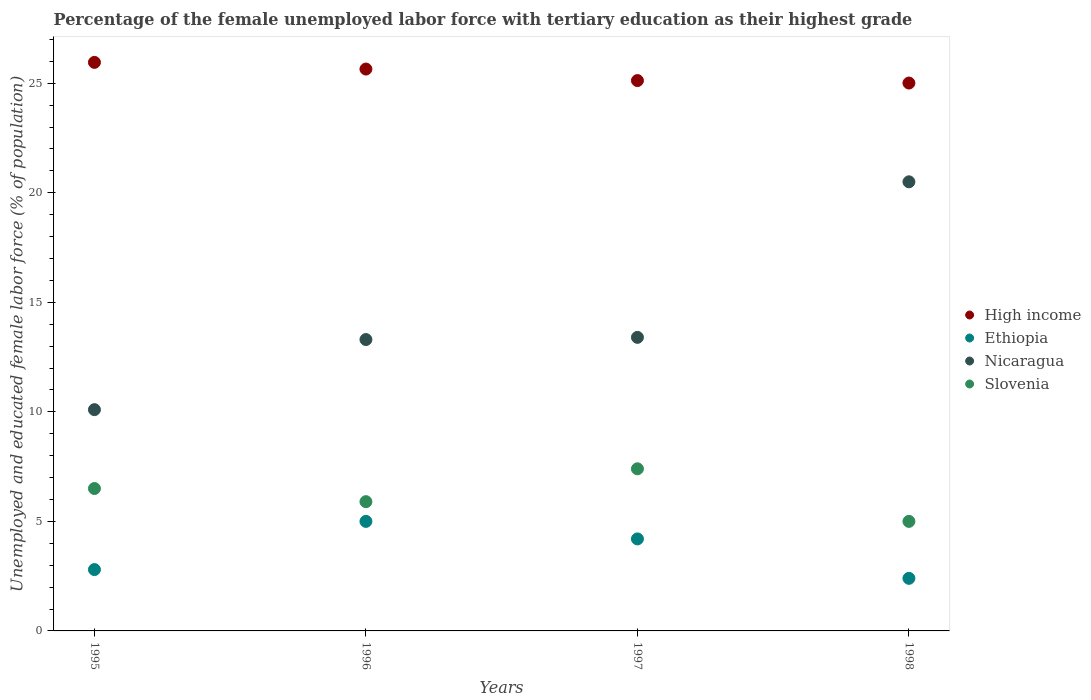Is the number of dotlines equal to the number of legend labels?
Make the answer very short. Yes. What is the percentage of the unemployed female labor force with tertiary education in Ethiopia in 1995?
Offer a very short reply. 2.8. Across all years, what is the minimum percentage of the unemployed female labor force with tertiary education in Nicaragua?
Provide a succinct answer. 10.1. What is the total percentage of the unemployed female labor force with tertiary education in Ethiopia in the graph?
Give a very brief answer. 14.4. What is the difference between the percentage of the unemployed female labor force with tertiary education in Nicaragua in 1995 and that in 1998?
Offer a terse response. -10.4. What is the difference between the percentage of the unemployed female labor force with tertiary education in Nicaragua in 1995 and the percentage of the unemployed female labor force with tertiary education in Ethiopia in 1996?
Provide a short and direct response. 5.1. What is the average percentage of the unemployed female labor force with tertiary education in Slovenia per year?
Your answer should be compact. 6.2. In the year 1998, what is the difference between the percentage of the unemployed female labor force with tertiary education in Slovenia and percentage of the unemployed female labor force with tertiary education in Ethiopia?
Make the answer very short. 2.6. In how many years, is the percentage of the unemployed female labor force with tertiary education in Slovenia greater than 19 %?
Make the answer very short. 0. What is the ratio of the percentage of the unemployed female labor force with tertiary education in Nicaragua in 1995 to that in 1997?
Ensure brevity in your answer.  0.75. Is the percentage of the unemployed female labor force with tertiary education in Ethiopia in 1995 less than that in 1996?
Make the answer very short. Yes. What is the difference between the highest and the second highest percentage of the unemployed female labor force with tertiary education in Ethiopia?
Your answer should be very brief. 0.8. What is the difference between the highest and the lowest percentage of the unemployed female labor force with tertiary education in High income?
Your answer should be very brief. 0.94. In how many years, is the percentage of the unemployed female labor force with tertiary education in High income greater than the average percentage of the unemployed female labor force with tertiary education in High income taken over all years?
Keep it short and to the point. 2. Is the sum of the percentage of the unemployed female labor force with tertiary education in Ethiopia in 1995 and 1998 greater than the maximum percentage of the unemployed female labor force with tertiary education in Nicaragua across all years?
Provide a short and direct response. No. Is it the case that in every year, the sum of the percentage of the unemployed female labor force with tertiary education in Slovenia and percentage of the unemployed female labor force with tertiary education in Nicaragua  is greater than the sum of percentage of the unemployed female labor force with tertiary education in High income and percentage of the unemployed female labor force with tertiary education in Ethiopia?
Provide a short and direct response. Yes. Is it the case that in every year, the sum of the percentage of the unemployed female labor force with tertiary education in Nicaragua and percentage of the unemployed female labor force with tertiary education in High income  is greater than the percentage of the unemployed female labor force with tertiary education in Ethiopia?
Your response must be concise. Yes. Does the percentage of the unemployed female labor force with tertiary education in Slovenia monotonically increase over the years?
Your response must be concise. No. Does the graph contain any zero values?
Make the answer very short. No. Does the graph contain grids?
Your answer should be compact. No. What is the title of the graph?
Give a very brief answer. Percentage of the female unemployed labor force with tertiary education as their highest grade. What is the label or title of the X-axis?
Ensure brevity in your answer.  Years. What is the label or title of the Y-axis?
Keep it short and to the point. Unemployed and educated female labor force (% of population). What is the Unemployed and educated female labor force (% of population) in High income in 1995?
Your response must be concise. 25.95. What is the Unemployed and educated female labor force (% of population) in Ethiopia in 1995?
Offer a terse response. 2.8. What is the Unemployed and educated female labor force (% of population) of Nicaragua in 1995?
Your response must be concise. 10.1. What is the Unemployed and educated female labor force (% of population) in High income in 1996?
Make the answer very short. 25.65. What is the Unemployed and educated female labor force (% of population) in Ethiopia in 1996?
Keep it short and to the point. 5. What is the Unemployed and educated female labor force (% of population) in Nicaragua in 1996?
Your answer should be very brief. 13.3. What is the Unemployed and educated female labor force (% of population) of Slovenia in 1996?
Your answer should be very brief. 5.9. What is the Unemployed and educated female labor force (% of population) of High income in 1997?
Your answer should be compact. 25.12. What is the Unemployed and educated female labor force (% of population) in Ethiopia in 1997?
Offer a terse response. 4.2. What is the Unemployed and educated female labor force (% of population) in Nicaragua in 1997?
Offer a very short reply. 13.4. What is the Unemployed and educated female labor force (% of population) of Slovenia in 1997?
Offer a very short reply. 7.4. What is the Unemployed and educated female labor force (% of population) of High income in 1998?
Your response must be concise. 25.01. What is the Unemployed and educated female labor force (% of population) in Ethiopia in 1998?
Ensure brevity in your answer.  2.4. What is the Unemployed and educated female labor force (% of population) in Slovenia in 1998?
Provide a short and direct response. 5. Across all years, what is the maximum Unemployed and educated female labor force (% of population) of High income?
Your answer should be very brief. 25.95. Across all years, what is the maximum Unemployed and educated female labor force (% of population) of Nicaragua?
Provide a short and direct response. 20.5. Across all years, what is the maximum Unemployed and educated female labor force (% of population) in Slovenia?
Give a very brief answer. 7.4. Across all years, what is the minimum Unemployed and educated female labor force (% of population) of High income?
Offer a terse response. 25.01. Across all years, what is the minimum Unemployed and educated female labor force (% of population) of Ethiopia?
Your answer should be very brief. 2.4. Across all years, what is the minimum Unemployed and educated female labor force (% of population) of Nicaragua?
Ensure brevity in your answer.  10.1. What is the total Unemployed and educated female labor force (% of population) in High income in the graph?
Ensure brevity in your answer.  101.73. What is the total Unemployed and educated female labor force (% of population) of Nicaragua in the graph?
Your response must be concise. 57.3. What is the total Unemployed and educated female labor force (% of population) of Slovenia in the graph?
Ensure brevity in your answer.  24.8. What is the difference between the Unemployed and educated female labor force (% of population) in High income in 1995 and that in 1996?
Give a very brief answer. 0.3. What is the difference between the Unemployed and educated female labor force (% of population) in Ethiopia in 1995 and that in 1996?
Make the answer very short. -2.2. What is the difference between the Unemployed and educated female labor force (% of population) of High income in 1995 and that in 1997?
Provide a succinct answer. 0.83. What is the difference between the Unemployed and educated female labor force (% of population) of Ethiopia in 1995 and that in 1997?
Your answer should be very brief. -1.4. What is the difference between the Unemployed and educated female labor force (% of population) in Nicaragua in 1995 and that in 1997?
Your response must be concise. -3.3. What is the difference between the Unemployed and educated female labor force (% of population) in Slovenia in 1995 and that in 1997?
Your answer should be compact. -0.9. What is the difference between the Unemployed and educated female labor force (% of population) of High income in 1995 and that in 1998?
Your answer should be compact. 0.94. What is the difference between the Unemployed and educated female labor force (% of population) in High income in 1996 and that in 1997?
Your answer should be very brief. 0.53. What is the difference between the Unemployed and educated female labor force (% of population) of Slovenia in 1996 and that in 1997?
Your response must be concise. -1.5. What is the difference between the Unemployed and educated female labor force (% of population) of High income in 1996 and that in 1998?
Keep it short and to the point. 0.64. What is the difference between the Unemployed and educated female labor force (% of population) in High income in 1997 and that in 1998?
Provide a succinct answer. 0.11. What is the difference between the Unemployed and educated female labor force (% of population) in Ethiopia in 1997 and that in 1998?
Give a very brief answer. 1.8. What is the difference between the Unemployed and educated female labor force (% of population) in Nicaragua in 1997 and that in 1998?
Provide a succinct answer. -7.1. What is the difference between the Unemployed and educated female labor force (% of population) in Slovenia in 1997 and that in 1998?
Your answer should be compact. 2.4. What is the difference between the Unemployed and educated female labor force (% of population) of High income in 1995 and the Unemployed and educated female labor force (% of population) of Ethiopia in 1996?
Give a very brief answer. 20.95. What is the difference between the Unemployed and educated female labor force (% of population) in High income in 1995 and the Unemployed and educated female labor force (% of population) in Nicaragua in 1996?
Your answer should be compact. 12.65. What is the difference between the Unemployed and educated female labor force (% of population) in High income in 1995 and the Unemployed and educated female labor force (% of population) in Slovenia in 1996?
Make the answer very short. 20.05. What is the difference between the Unemployed and educated female labor force (% of population) of Ethiopia in 1995 and the Unemployed and educated female labor force (% of population) of Nicaragua in 1996?
Keep it short and to the point. -10.5. What is the difference between the Unemployed and educated female labor force (% of population) in Ethiopia in 1995 and the Unemployed and educated female labor force (% of population) in Slovenia in 1996?
Ensure brevity in your answer.  -3.1. What is the difference between the Unemployed and educated female labor force (% of population) of High income in 1995 and the Unemployed and educated female labor force (% of population) of Ethiopia in 1997?
Make the answer very short. 21.75. What is the difference between the Unemployed and educated female labor force (% of population) in High income in 1995 and the Unemployed and educated female labor force (% of population) in Nicaragua in 1997?
Your response must be concise. 12.55. What is the difference between the Unemployed and educated female labor force (% of population) in High income in 1995 and the Unemployed and educated female labor force (% of population) in Slovenia in 1997?
Your answer should be very brief. 18.55. What is the difference between the Unemployed and educated female labor force (% of population) of Ethiopia in 1995 and the Unemployed and educated female labor force (% of population) of Slovenia in 1997?
Offer a very short reply. -4.6. What is the difference between the Unemployed and educated female labor force (% of population) in High income in 1995 and the Unemployed and educated female labor force (% of population) in Ethiopia in 1998?
Ensure brevity in your answer.  23.55. What is the difference between the Unemployed and educated female labor force (% of population) of High income in 1995 and the Unemployed and educated female labor force (% of population) of Nicaragua in 1998?
Your answer should be compact. 5.45. What is the difference between the Unemployed and educated female labor force (% of population) in High income in 1995 and the Unemployed and educated female labor force (% of population) in Slovenia in 1998?
Make the answer very short. 20.95. What is the difference between the Unemployed and educated female labor force (% of population) of Ethiopia in 1995 and the Unemployed and educated female labor force (% of population) of Nicaragua in 1998?
Your response must be concise. -17.7. What is the difference between the Unemployed and educated female labor force (% of population) in High income in 1996 and the Unemployed and educated female labor force (% of population) in Ethiopia in 1997?
Your answer should be compact. 21.45. What is the difference between the Unemployed and educated female labor force (% of population) in High income in 1996 and the Unemployed and educated female labor force (% of population) in Nicaragua in 1997?
Your answer should be compact. 12.25. What is the difference between the Unemployed and educated female labor force (% of population) of High income in 1996 and the Unemployed and educated female labor force (% of population) of Slovenia in 1997?
Your answer should be very brief. 18.25. What is the difference between the Unemployed and educated female labor force (% of population) in High income in 1996 and the Unemployed and educated female labor force (% of population) in Ethiopia in 1998?
Offer a very short reply. 23.25. What is the difference between the Unemployed and educated female labor force (% of population) in High income in 1996 and the Unemployed and educated female labor force (% of population) in Nicaragua in 1998?
Make the answer very short. 5.15. What is the difference between the Unemployed and educated female labor force (% of population) of High income in 1996 and the Unemployed and educated female labor force (% of population) of Slovenia in 1998?
Make the answer very short. 20.65. What is the difference between the Unemployed and educated female labor force (% of population) of Ethiopia in 1996 and the Unemployed and educated female labor force (% of population) of Nicaragua in 1998?
Provide a short and direct response. -15.5. What is the difference between the Unemployed and educated female labor force (% of population) of Nicaragua in 1996 and the Unemployed and educated female labor force (% of population) of Slovenia in 1998?
Give a very brief answer. 8.3. What is the difference between the Unemployed and educated female labor force (% of population) of High income in 1997 and the Unemployed and educated female labor force (% of population) of Ethiopia in 1998?
Provide a short and direct response. 22.72. What is the difference between the Unemployed and educated female labor force (% of population) in High income in 1997 and the Unemployed and educated female labor force (% of population) in Nicaragua in 1998?
Your answer should be very brief. 4.62. What is the difference between the Unemployed and educated female labor force (% of population) of High income in 1997 and the Unemployed and educated female labor force (% of population) of Slovenia in 1998?
Ensure brevity in your answer.  20.12. What is the difference between the Unemployed and educated female labor force (% of population) of Ethiopia in 1997 and the Unemployed and educated female labor force (% of population) of Nicaragua in 1998?
Ensure brevity in your answer.  -16.3. What is the average Unemployed and educated female labor force (% of population) in High income per year?
Offer a very short reply. 25.43. What is the average Unemployed and educated female labor force (% of population) of Nicaragua per year?
Your answer should be very brief. 14.32. What is the average Unemployed and educated female labor force (% of population) of Slovenia per year?
Provide a succinct answer. 6.2. In the year 1995, what is the difference between the Unemployed and educated female labor force (% of population) of High income and Unemployed and educated female labor force (% of population) of Ethiopia?
Make the answer very short. 23.15. In the year 1995, what is the difference between the Unemployed and educated female labor force (% of population) of High income and Unemployed and educated female labor force (% of population) of Nicaragua?
Ensure brevity in your answer.  15.85. In the year 1995, what is the difference between the Unemployed and educated female labor force (% of population) in High income and Unemployed and educated female labor force (% of population) in Slovenia?
Your answer should be very brief. 19.45. In the year 1995, what is the difference between the Unemployed and educated female labor force (% of population) of Ethiopia and Unemployed and educated female labor force (% of population) of Nicaragua?
Your response must be concise. -7.3. In the year 1995, what is the difference between the Unemployed and educated female labor force (% of population) in Ethiopia and Unemployed and educated female labor force (% of population) in Slovenia?
Your answer should be very brief. -3.7. In the year 1995, what is the difference between the Unemployed and educated female labor force (% of population) in Nicaragua and Unemployed and educated female labor force (% of population) in Slovenia?
Make the answer very short. 3.6. In the year 1996, what is the difference between the Unemployed and educated female labor force (% of population) in High income and Unemployed and educated female labor force (% of population) in Ethiopia?
Offer a very short reply. 20.65. In the year 1996, what is the difference between the Unemployed and educated female labor force (% of population) of High income and Unemployed and educated female labor force (% of population) of Nicaragua?
Ensure brevity in your answer.  12.35. In the year 1996, what is the difference between the Unemployed and educated female labor force (% of population) of High income and Unemployed and educated female labor force (% of population) of Slovenia?
Provide a short and direct response. 19.75. In the year 1996, what is the difference between the Unemployed and educated female labor force (% of population) of Ethiopia and Unemployed and educated female labor force (% of population) of Nicaragua?
Make the answer very short. -8.3. In the year 1996, what is the difference between the Unemployed and educated female labor force (% of population) in Ethiopia and Unemployed and educated female labor force (% of population) in Slovenia?
Offer a terse response. -0.9. In the year 1997, what is the difference between the Unemployed and educated female labor force (% of population) of High income and Unemployed and educated female labor force (% of population) of Ethiopia?
Make the answer very short. 20.92. In the year 1997, what is the difference between the Unemployed and educated female labor force (% of population) of High income and Unemployed and educated female labor force (% of population) of Nicaragua?
Offer a terse response. 11.72. In the year 1997, what is the difference between the Unemployed and educated female labor force (% of population) in High income and Unemployed and educated female labor force (% of population) in Slovenia?
Ensure brevity in your answer.  17.72. In the year 1997, what is the difference between the Unemployed and educated female labor force (% of population) of Ethiopia and Unemployed and educated female labor force (% of population) of Nicaragua?
Ensure brevity in your answer.  -9.2. In the year 1997, what is the difference between the Unemployed and educated female labor force (% of population) of Ethiopia and Unemployed and educated female labor force (% of population) of Slovenia?
Your answer should be compact. -3.2. In the year 1998, what is the difference between the Unemployed and educated female labor force (% of population) in High income and Unemployed and educated female labor force (% of population) in Ethiopia?
Ensure brevity in your answer.  22.61. In the year 1998, what is the difference between the Unemployed and educated female labor force (% of population) in High income and Unemployed and educated female labor force (% of population) in Nicaragua?
Provide a succinct answer. 4.51. In the year 1998, what is the difference between the Unemployed and educated female labor force (% of population) in High income and Unemployed and educated female labor force (% of population) in Slovenia?
Your response must be concise. 20.01. In the year 1998, what is the difference between the Unemployed and educated female labor force (% of population) in Ethiopia and Unemployed and educated female labor force (% of population) in Nicaragua?
Keep it short and to the point. -18.1. In the year 1998, what is the difference between the Unemployed and educated female labor force (% of population) of Nicaragua and Unemployed and educated female labor force (% of population) of Slovenia?
Your answer should be very brief. 15.5. What is the ratio of the Unemployed and educated female labor force (% of population) in High income in 1995 to that in 1996?
Keep it short and to the point. 1.01. What is the ratio of the Unemployed and educated female labor force (% of population) in Ethiopia in 1995 to that in 1996?
Offer a very short reply. 0.56. What is the ratio of the Unemployed and educated female labor force (% of population) of Nicaragua in 1995 to that in 1996?
Offer a terse response. 0.76. What is the ratio of the Unemployed and educated female labor force (% of population) in Slovenia in 1995 to that in 1996?
Your answer should be compact. 1.1. What is the ratio of the Unemployed and educated female labor force (% of population) in High income in 1995 to that in 1997?
Your answer should be compact. 1.03. What is the ratio of the Unemployed and educated female labor force (% of population) of Nicaragua in 1995 to that in 1997?
Your answer should be compact. 0.75. What is the ratio of the Unemployed and educated female labor force (% of population) in Slovenia in 1995 to that in 1997?
Provide a short and direct response. 0.88. What is the ratio of the Unemployed and educated female labor force (% of population) of High income in 1995 to that in 1998?
Give a very brief answer. 1.04. What is the ratio of the Unemployed and educated female labor force (% of population) in Nicaragua in 1995 to that in 1998?
Offer a terse response. 0.49. What is the ratio of the Unemployed and educated female labor force (% of population) of High income in 1996 to that in 1997?
Give a very brief answer. 1.02. What is the ratio of the Unemployed and educated female labor force (% of population) of Ethiopia in 1996 to that in 1997?
Ensure brevity in your answer.  1.19. What is the ratio of the Unemployed and educated female labor force (% of population) of Nicaragua in 1996 to that in 1997?
Keep it short and to the point. 0.99. What is the ratio of the Unemployed and educated female labor force (% of population) of Slovenia in 1996 to that in 1997?
Keep it short and to the point. 0.8. What is the ratio of the Unemployed and educated female labor force (% of population) in High income in 1996 to that in 1998?
Your response must be concise. 1.03. What is the ratio of the Unemployed and educated female labor force (% of population) of Ethiopia in 1996 to that in 1998?
Keep it short and to the point. 2.08. What is the ratio of the Unemployed and educated female labor force (% of population) of Nicaragua in 1996 to that in 1998?
Offer a terse response. 0.65. What is the ratio of the Unemployed and educated female labor force (% of population) in Slovenia in 1996 to that in 1998?
Ensure brevity in your answer.  1.18. What is the ratio of the Unemployed and educated female labor force (% of population) of Ethiopia in 1997 to that in 1998?
Offer a terse response. 1.75. What is the ratio of the Unemployed and educated female labor force (% of population) of Nicaragua in 1997 to that in 1998?
Your answer should be very brief. 0.65. What is the ratio of the Unemployed and educated female labor force (% of population) of Slovenia in 1997 to that in 1998?
Offer a terse response. 1.48. What is the difference between the highest and the second highest Unemployed and educated female labor force (% of population) of High income?
Provide a succinct answer. 0.3. What is the difference between the highest and the second highest Unemployed and educated female labor force (% of population) of Slovenia?
Your response must be concise. 0.9. What is the difference between the highest and the lowest Unemployed and educated female labor force (% of population) of High income?
Provide a short and direct response. 0.94. What is the difference between the highest and the lowest Unemployed and educated female labor force (% of population) of Nicaragua?
Give a very brief answer. 10.4. What is the difference between the highest and the lowest Unemployed and educated female labor force (% of population) of Slovenia?
Provide a succinct answer. 2.4. 